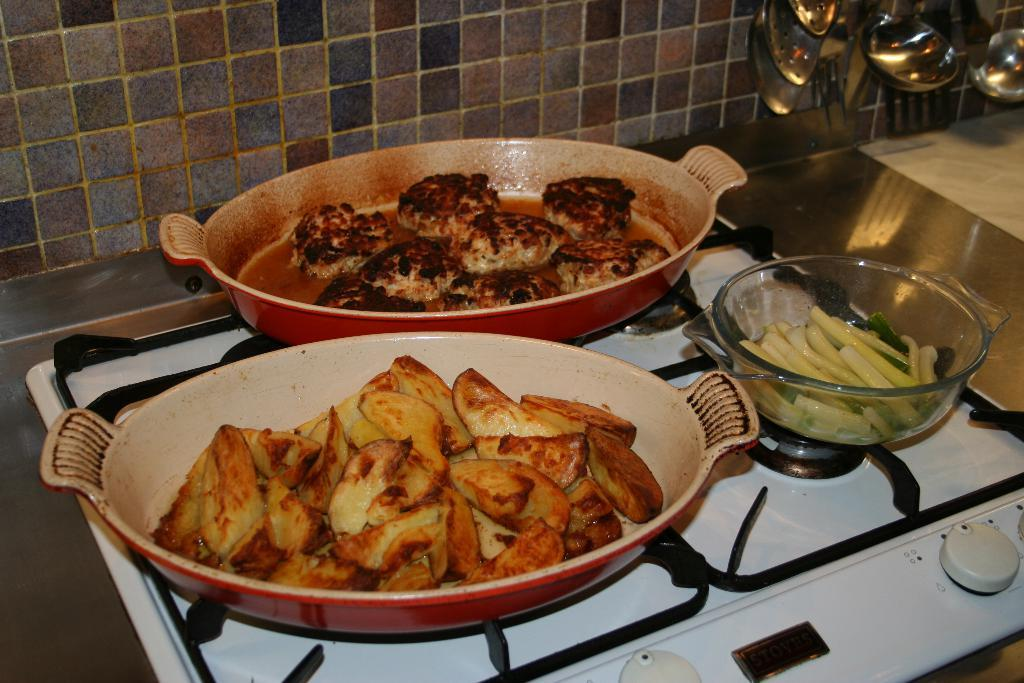What is present in the trays in the image? There is food in the trays in the image. What is the food being prepared on in the image? There is food in a bowl on a gas stove in the image. What utensils are visible in the image? There are serving spoons visible in the image. How does the rainstorm affect the food preparation in the image? There is no rainstorm present in the image, so it does not affect the food preparation. 